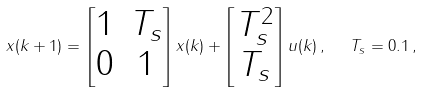Convert formula to latex. <formula><loc_0><loc_0><loc_500><loc_500>x ( k + 1 ) = \begin{bmatrix} 1 & T _ { s } \\ 0 & 1 \end{bmatrix} x ( k ) + \begin{bmatrix} T _ { s } ^ { 2 } \\ T _ { s } \end{bmatrix} u ( k ) \, , \ \ T _ { s } = 0 . 1 \, ,</formula> 